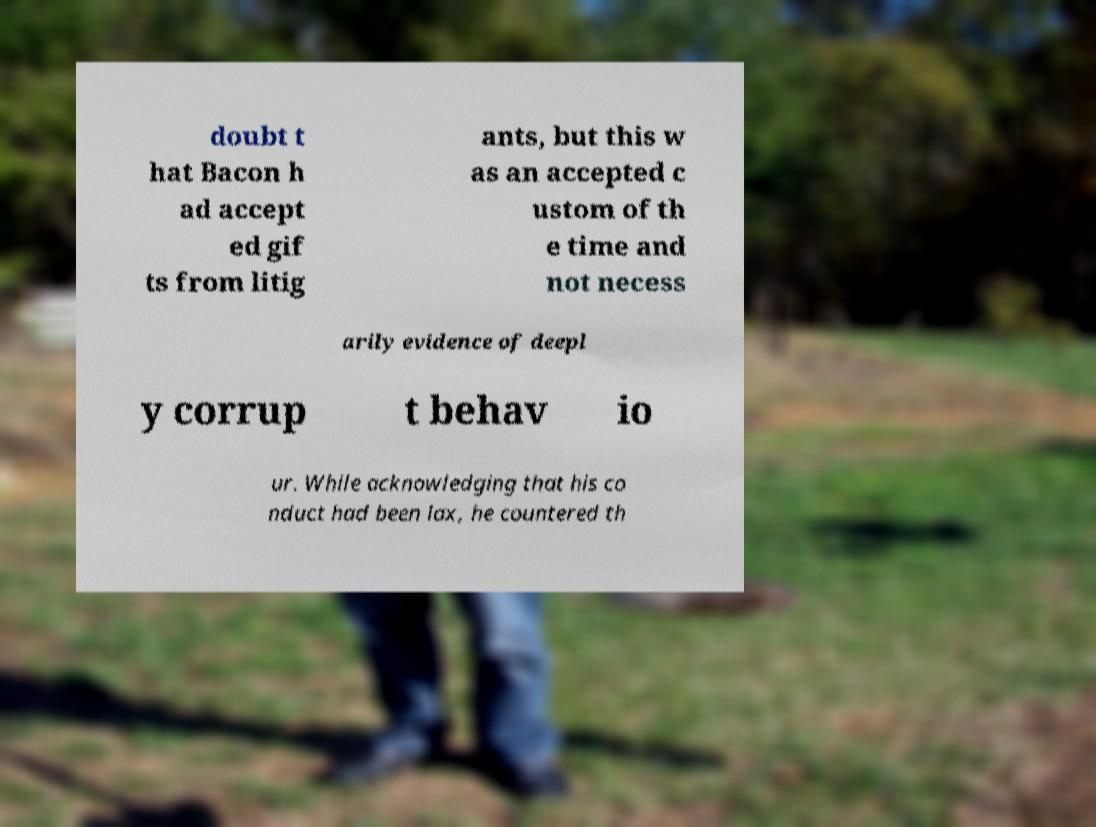There's text embedded in this image that I need extracted. Can you transcribe it verbatim? doubt t hat Bacon h ad accept ed gif ts from litig ants, but this w as an accepted c ustom of th e time and not necess arily evidence of deepl y corrup t behav io ur. While acknowledging that his co nduct had been lax, he countered th 